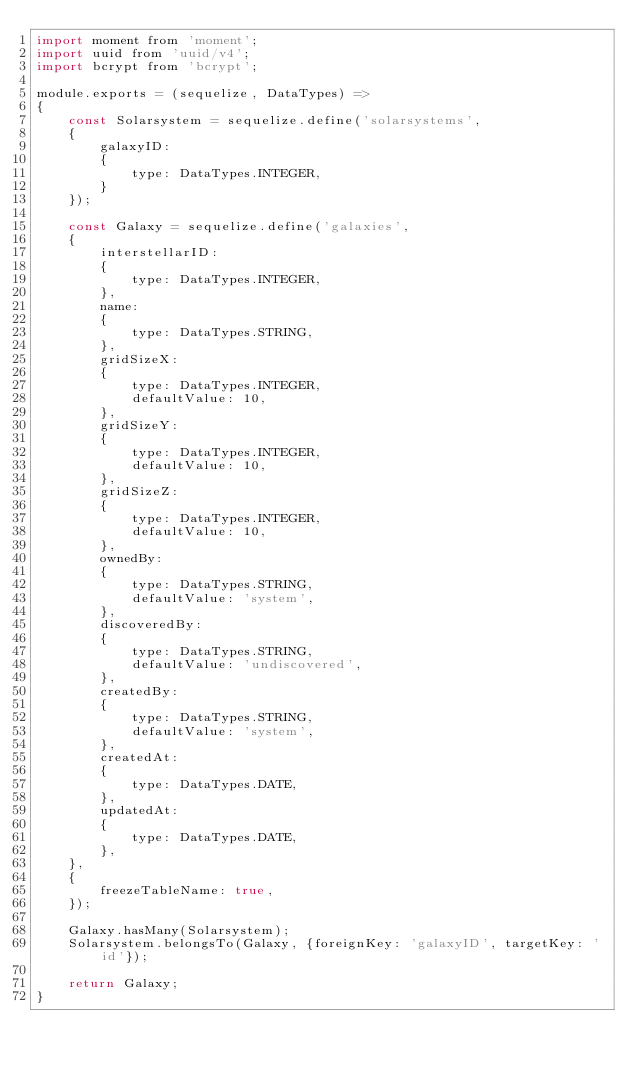Convert code to text. <code><loc_0><loc_0><loc_500><loc_500><_JavaScript_>import moment from 'moment';
import uuid from 'uuid/v4';
import bcrypt from 'bcrypt';

module.exports = (sequelize, DataTypes) =>
{
	const Solarsystem = sequelize.define('solarsystems',
	{
		galaxyID:
		{
			type: DataTypes.INTEGER,
		}
	});

	const Galaxy = sequelize.define('galaxies',
	{
		interstellarID:
		{
			type: DataTypes.INTEGER,
		},
		name:
		{
			type: DataTypes.STRING,
		},
		gridSizeX:
		{
			type: DataTypes.INTEGER,
			defaultValue: 10,
		},
		gridSizeY:
		{
			type: DataTypes.INTEGER,
			defaultValue: 10,
		},
		gridSizeZ:
		{
			type: DataTypes.INTEGER,
			defaultValue: 10,
		},
		ownedBy:
		{
			type: DataTypes.STRING,
			defaultValue: 'system',
		},
		discoveredBy:
		{
			type: DataTypes.STRING,
			defaultValue: 'undiscovered',
		},
		createdBy:
		{
			type: DataTypes.STRING,
			defaultValue: 'system',
		},
		createdAt:
		{
			type: DataTypes.DATE,
		},
		updatedAt:
		{
			type: DataTypes.DATE,
		},
	},
	{
		freezeTableName: true,
	});

	Galaxy.hasMany(Solarsystem);
	Solarsystem.belongsTo(Galaxy, {foreignKey: 'galaxyID', targetKey: 'id'});

	return Galaxy;
}
</code> 